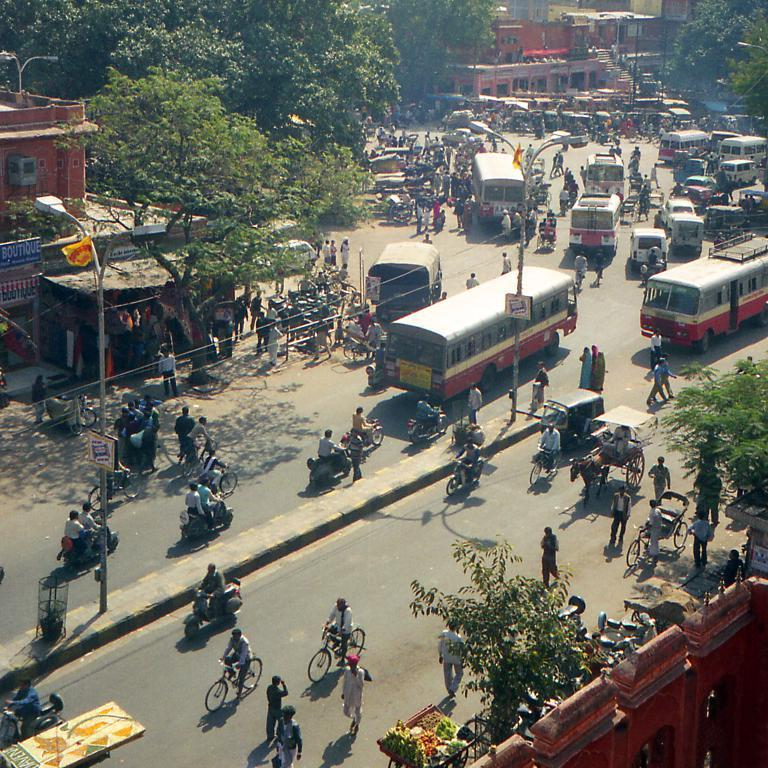<image>
Render a clear and concise summary of the photo. A busy street and town area has a boutique in a blue sign. 